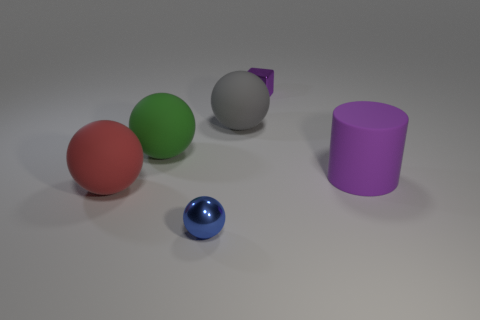Subtract all cyan spheres. Subtract all purple blocks. How many spheres are left? 4 Add 2 brown rubber things. How many objects exist? 8 Subtract all balls. How many objects are left? 2 Add 6 balls. How many balls are left? 10 Add 1 rubber cylinders. How many rubber cylinders exist? 2 Subtract 0 green cylinders. How many objects are left? 6 Subtract all red rubber cubes. Subtract all small blue things. How many objects are left? 5 